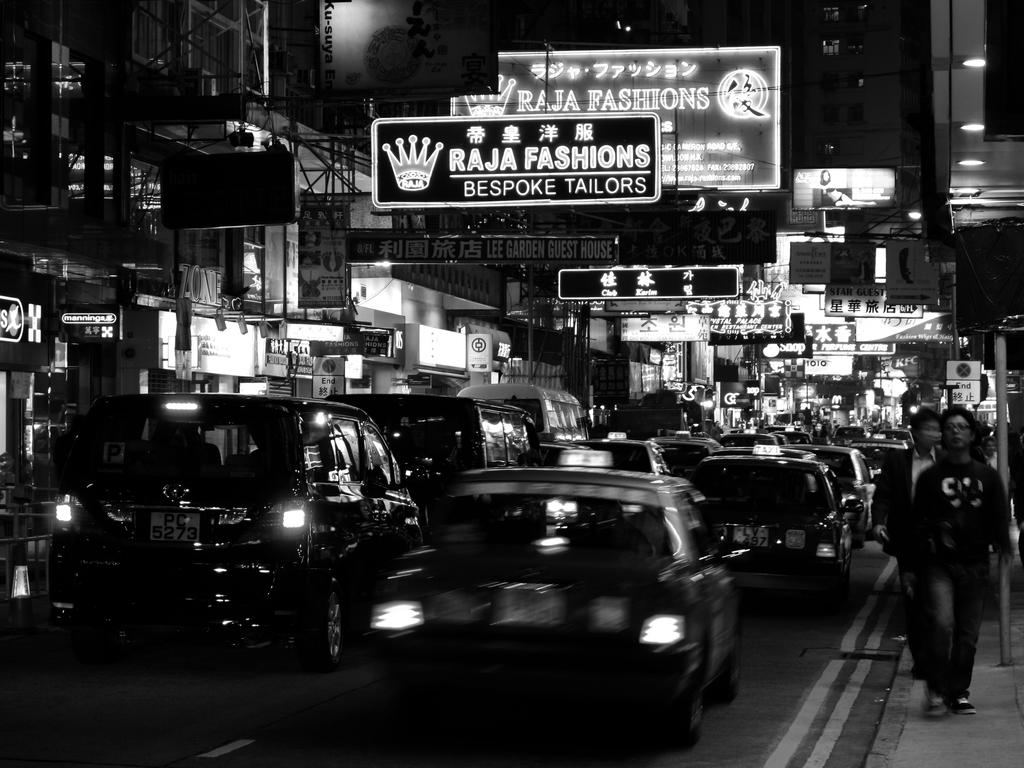What kind of tailors are advertised?
Your answer should be very brief. Bespoke. What kind of fashions?
Make the answer very short. Raja. 